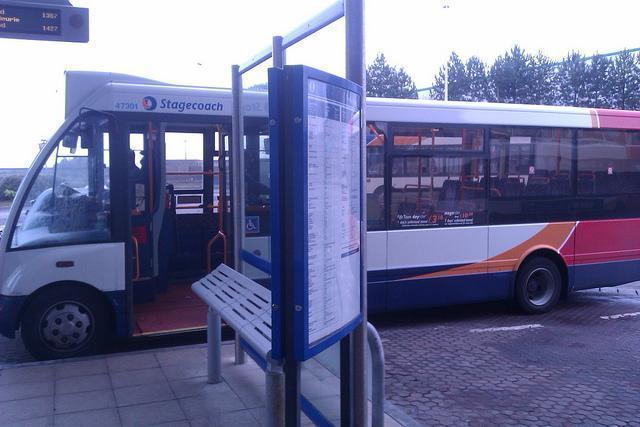How many ducks have orange hats?
Give a very brief answer. 0. 